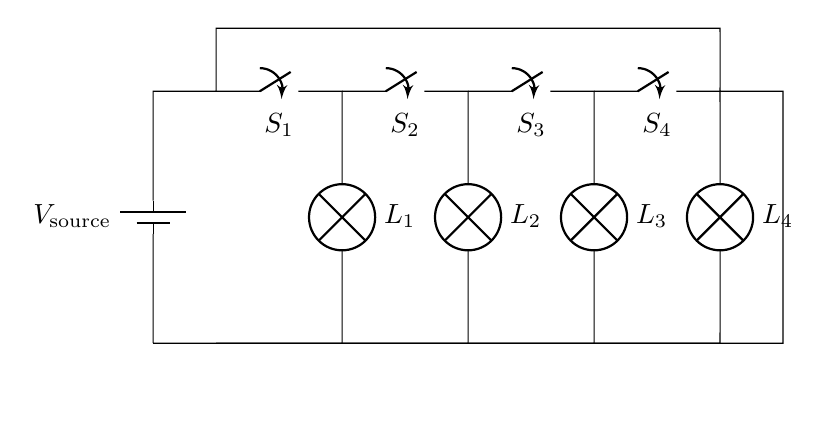What type of circuit is this? This circuit is a parallel circuit, as indicated by the arrangement of components where each lamp is connected across the same two points, allowing them to operate independently.
Answer: Parallel How many switches are present in the circuit? By counting the switch symbols in the diagram, we can see there are four switches labeled S1, S2, S3, and S4.
Answer: Four What is the function of the switches in this circuit? The switches control the flow of current to the lamps. When a switch is closed, it allows current to flow to its corresponding lamp, turning it on.
Answer: Control lamps What happens if one lamp fails in this circuit? In a parallel circuit, if one lamp fails (becomes an open circuit), the other lamps will continue to operate normally since they have separate paths for current.
Answer: Others continue What is the effect of closing all switches in this diagram? Closing all switches will complete the circuit for each lamp, allowing all lamps to light up simultaneously, as each switch provides a path for current to each lamp.
Answer: All lamps light What does the voltage source represent? The voltage source provides the necessary electrical energy for the circuit. It is the battery that maintains the potential difference across the circuit components.
Answer: Voltage source Are all lamps identical in this circuit? The circuit diagram does not specify different types for each lamp, suggesting they are identical. If they are the same type, they will share the same voltage across them.
Answer: Yes, identical 